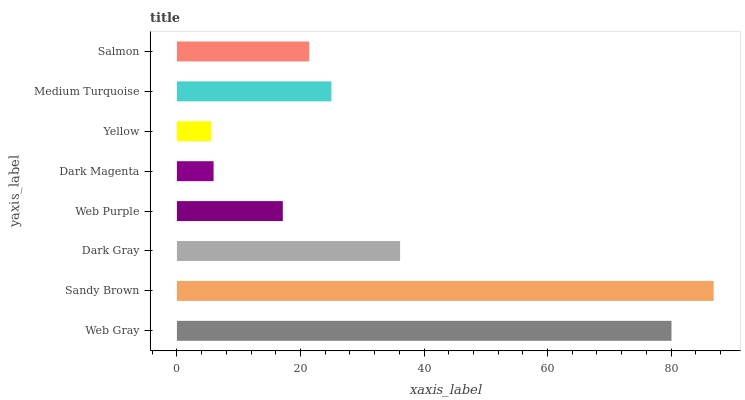Is Yellow the minimum?
Answer yes or no. Yes. Is Sandy Brown the maximum?
Answer yes or no. Yes. Is Dark Gray the minimum?
Answer yes or no. No. Is Dark Gray the maximum?
Answer yes or no. No. Is Sandy Brown greater than Dark Gray?
Answer yes or no. Yes. Is Dark Gray less than Sandy Brown?
Answer yes or no. Yes. Is Dark Gray greater than Sandy Brown?
Answer yes or no. No. Is Sandy Brown less than Dark Gray?
Answer yes or no. No. Is Medium Turquoise the high median?
Answer yes or no. Yes. Is Salmon the low median?
Answer yes or no. Yes. Is Dark Magenta the high median?
Answer yes or no. No. Is Dark Gray the low median?
Answer yes or no. No. 